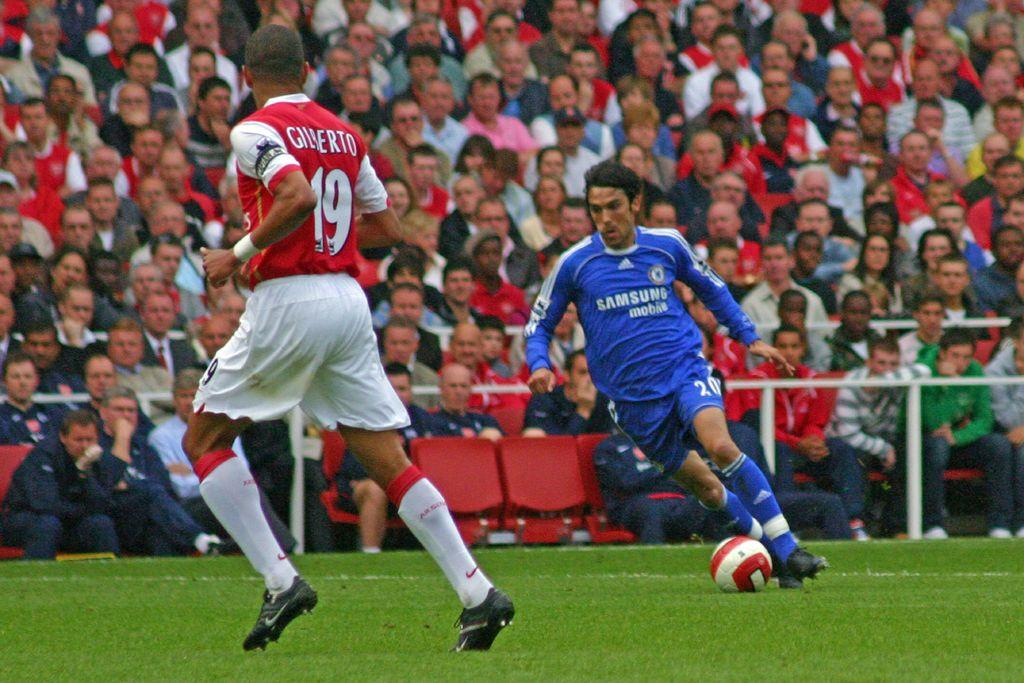What are the two men in the image doing? The two men in the image are running. Where are the men running? The men are running on the ground. What is on the ground besides the men? There is a ball on the ground. What can be seen in the background of the image? In the background, there is a group of people sitting on chairs. What are the people in the background doing? The group of people is looking at the two men running. What type of grass can be seen growing in the image? There is no grass visible in the image. 